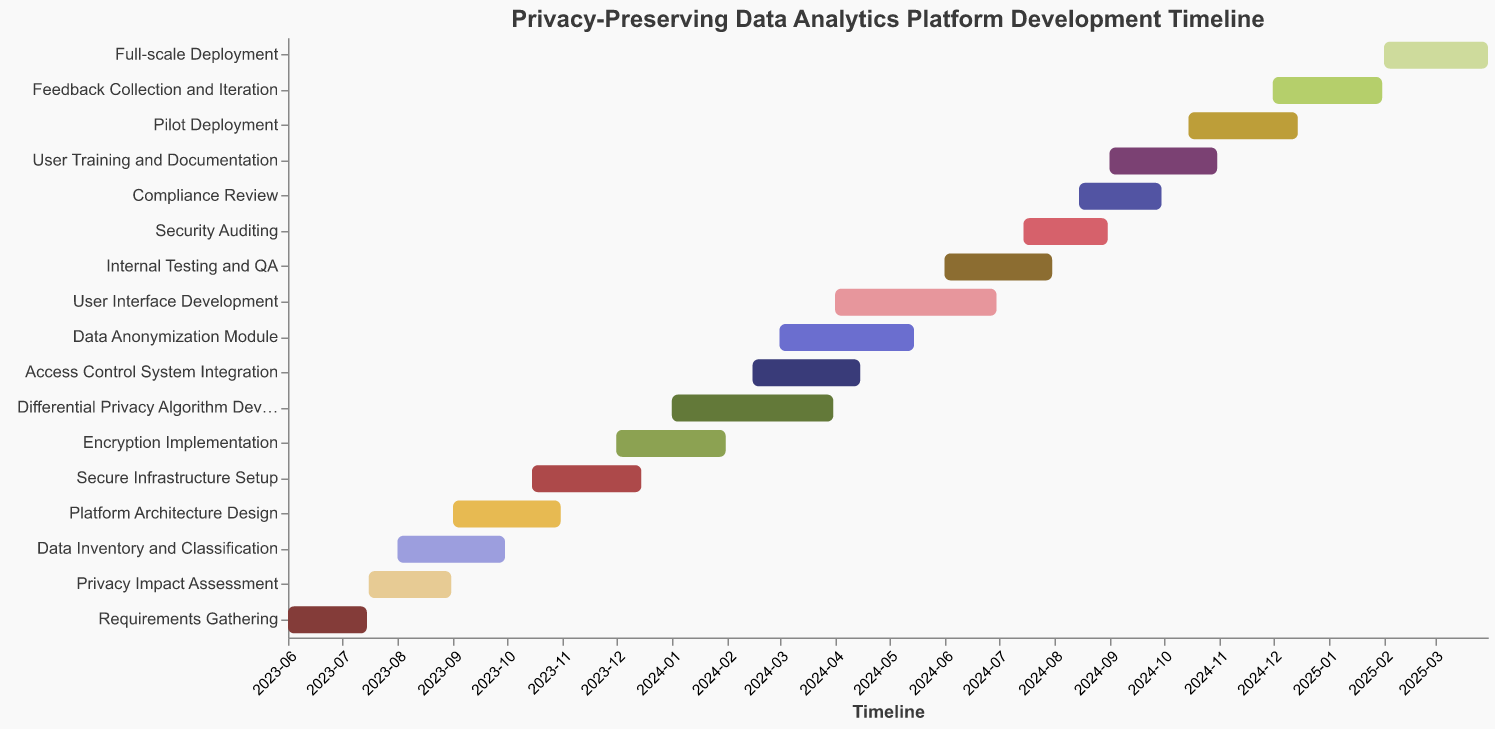What's the title of the Gantt chart? The title of the chart is located at the top and is usually set in a larger font to make it stand out.
Answer: Privacy-Preserving Data Analytics Platform Development Timeline How many tasks are shown in the Gantt chart? Count the number of different tasks listed along the y-axis of the Gantt chart.
Answer: 17 Which task starts first according to the Gantt chart? Look for the task that has the earliest start date, which would be positioned at the very beginning of the timeline.
Answer: Requirements Gathering What is the duration of the "Encryption Implementation" task? Find the start and end dates for "Encryption Implementation" and calculate the difference in days between these two dates.
Answer: 61 days Which tasks overlap with the "User Interface Development" task? Identify the start and end dates of the "User Interface Development" task and see which other tasks fall within this date range.
Answer: Access Control System Integration, Data Anonymization Module, Internal Testing and QA What are the start and end dates for the "Full-scale Deployment" phase? Look for the "Full-scale Deployment" task on the Gantt chart and note its start and end dates.
Answer: 2025-02-01 to 2025-03-31 When does the "Security Auditing" task take place? Locate the "Security Auditing" task on the Gantt chart to determine its start and end dates.
Answer: 2024-07-15 to 2024-08-31 How long after the "Requirements Gathering" does the "Platform Architecture Design" begin? Calculate the number of days between the end of "Requirements Gathering" and the start of "Platform Architecture Design".
Answer: 46 days Which task has the longest duration? Compare the durations of all tasks by looking at their start and end dates to figure out which one lasts the longest.
Answer: Data Inventory and Classification Is "Internal Testing and QA" completed before "Compliance Review" begins? Compare the end date of "Internal Testing and QA" with the start date of "Compliance Review" to see if the former is completed before the latter begins.
Answer: Yes 